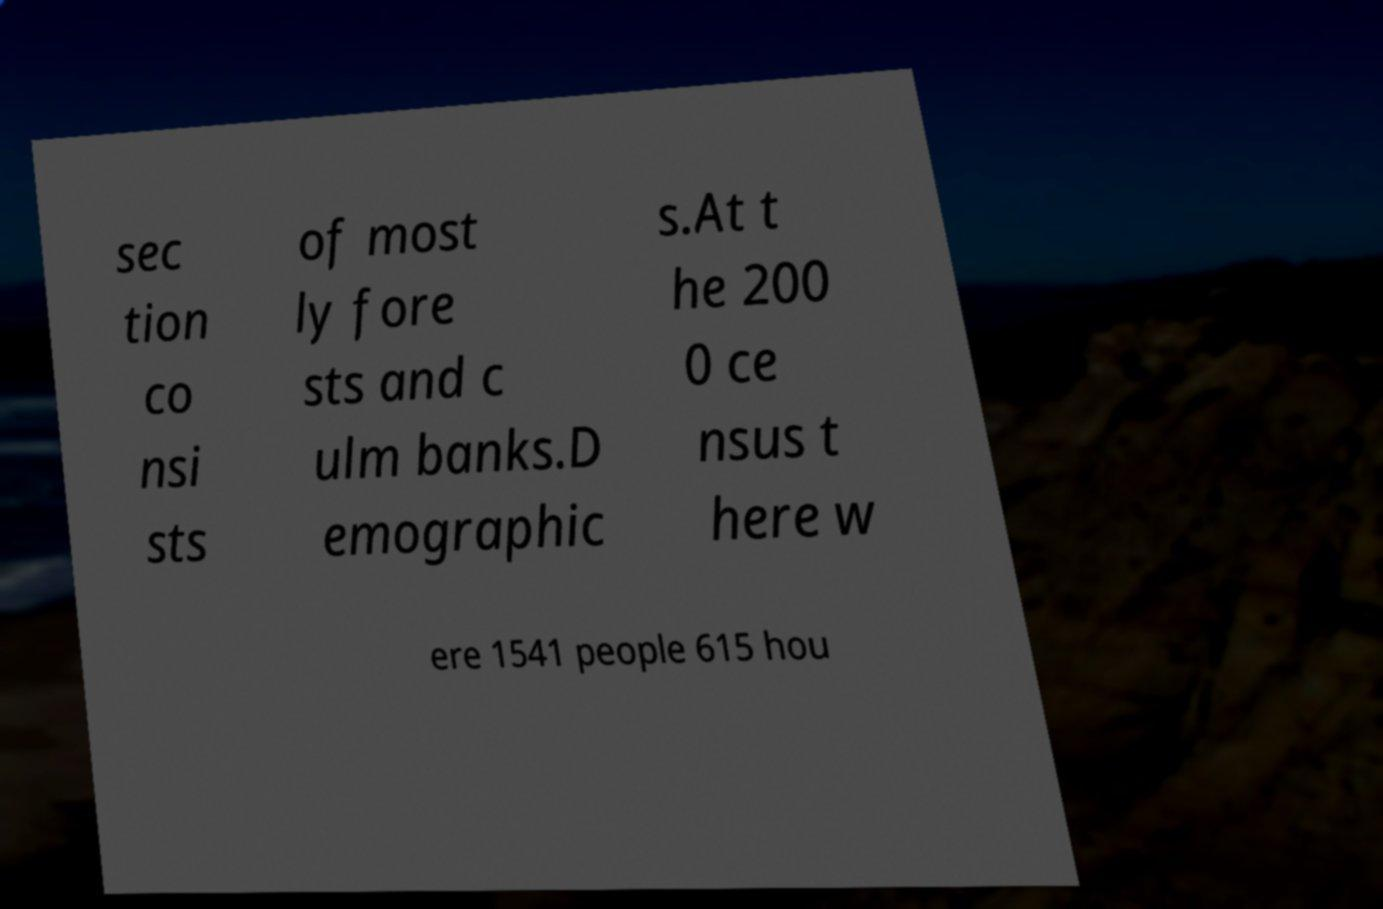What messages or text are displayed in this image? I need them in a readable, typed format. sec tion co nsi sts of most ly fore sts and c ulm banks.D emographic s.At t he 200 0 ce nsus t here w ere 1541 people 615 hou 